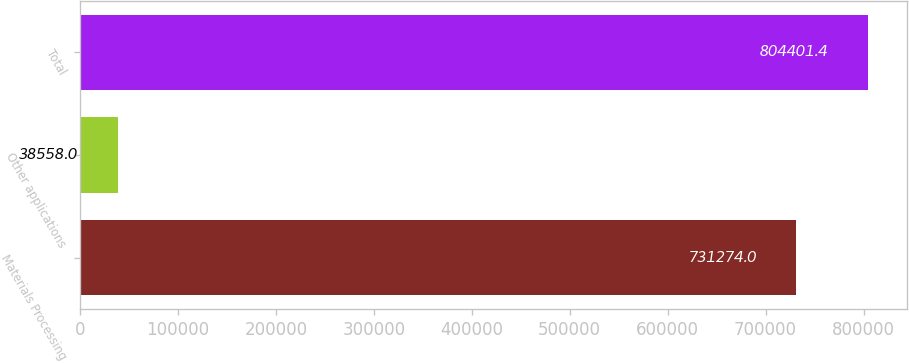Convert chart to OTSL. <chart><loc_0><loc_0><loc_500><loc_500><bar_chart><fcel>Materials Processing<fcel>Other applications<fcel>Total<nl><fcel>731274<fcel>38558<fcel>804401<nl></chart> 